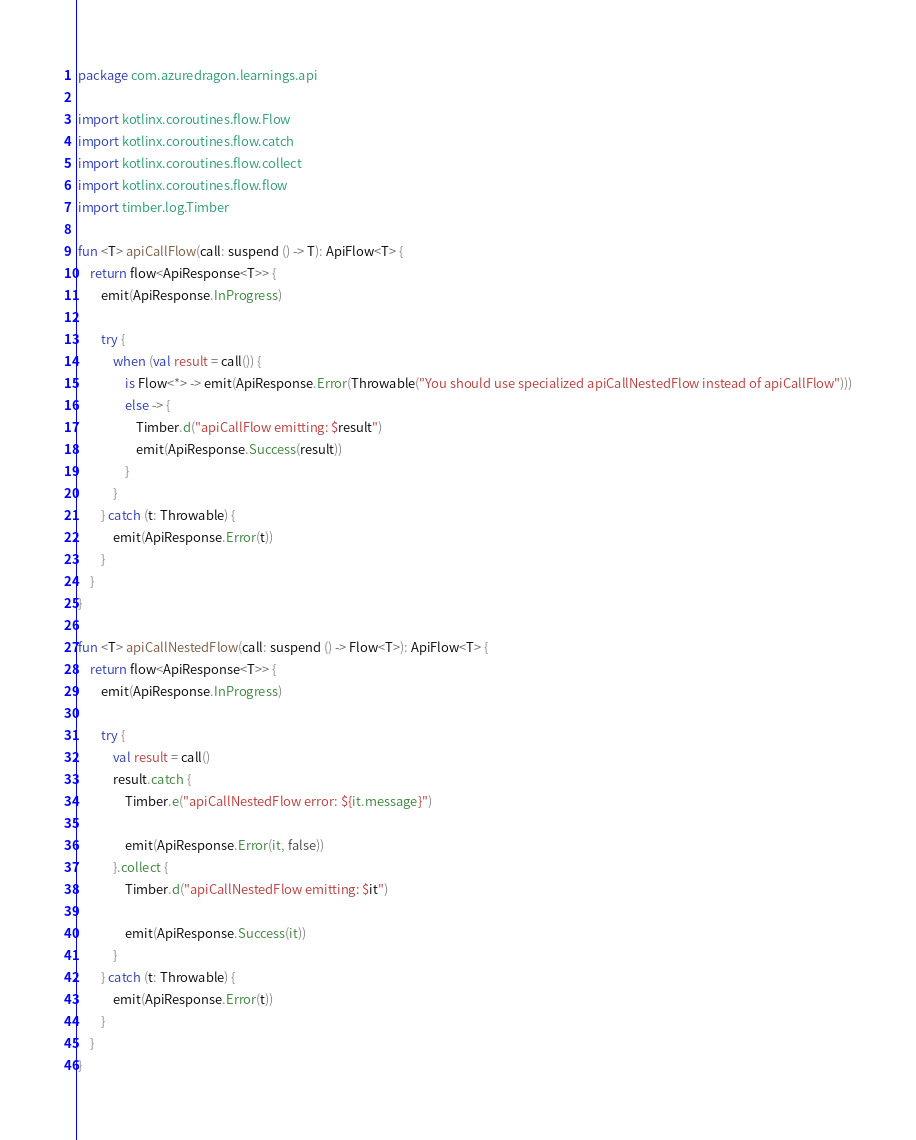<code> <loc_0><loc_0><loc_500><loc_500><_Kotlin_>package com.azuredragon.learnings.api

import kotlinx.coroutines.flow.Flow
import kotlinx.coroutines.flow.catch
import kotlinx.coroutines.flow.collect
import kotlinx.coroutines.flow.flow
import timber.log.Timber

fun <T> apiCallFlow(call: suspend () -> T): ApiFlow<T> {
    return flow<ApiResponse<T>> {
        emit(ApiResponse.InProgress)

        try {
            when (val result = call()) {
                is Flow<*> -> emit(ApiResponse.Error(Throwable("You should use specialized apiCallNestedFlow instead of apiCallFlow")))
                else -> {
                    Timber.d("apiCallFlow emitting: $result")
                    emit(ApiResponse.Success(result))
                }
            }
        } catch (t: Throwable) {
            emit(ApiResponse.Error(t))
        }
    }
}

fun <T> apiCallNestedFlow(call: suspend () -> Flow<T>): ApiFlow<T> {
    return flow<ApiResponse<T>> {
        emit(ApiResponse.InProgress)

        try {
            val result = call()
            result.catch {
                Timber.e("apiCallNestedFlow error: ${it.message}")

                emit(ApiResponse.Error(it, false))
            }.collect {
                Timber.d("apiCallNestedFlow emitting: $it")

                emit(ApiResponse.Success(it))
            }
        } catch (t: Throwable) {
            emit(ApiResponse.Error(t))
        }
    }
}</code> 